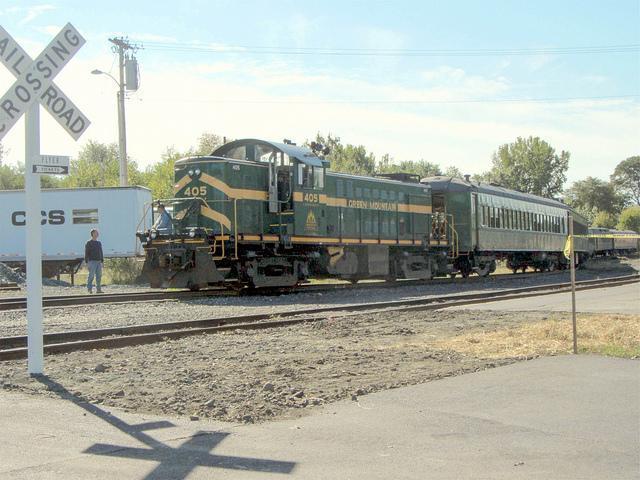How many rails do you see?
Give a very brief answer. 2. 